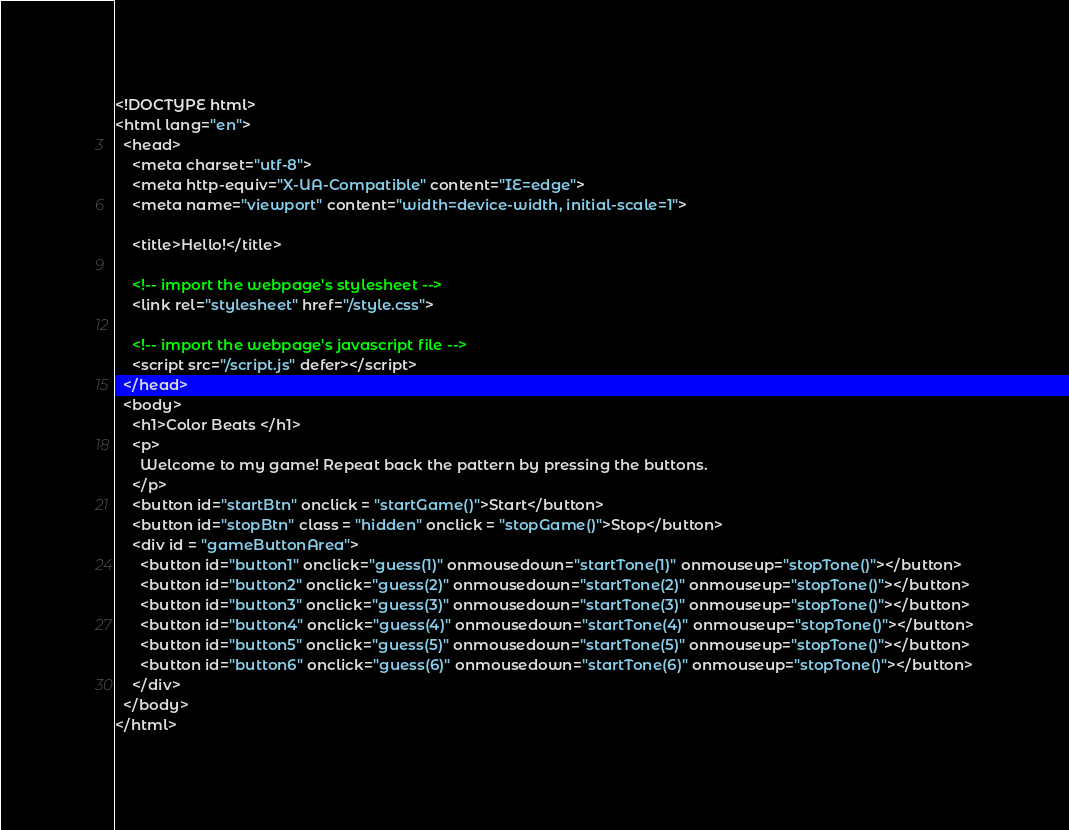Convert code to text. <code><loc_0><loc_0><loc_500><loc_500><_HTML_><!DOCTYPE html>
<html lang="en">
  <head>
    <meta charset="utf-8">
    <meta http-equiv="X-UA-Compatible" content="IE=edge">
    <meta name="viewport" content="width=device-width, initial-scale=1">

    <title>Hello!</title>
    
    <!-- import the webpage's stylesheet -->
    <link rel="stylesheet" href="/style.css">
    
    <!-- import the webpage's javascript file -->
    <script src="/script.js" defer></script>
  </head>  
  <body>
    <h1>Color Beats </h1>
    <p>
      Welcome to my game! Repeat back the pattern by pressing the buttons.
    </p>
    <button id="startBtn" onclick = "startGame()">Start</button>
    <button id="stopBtn" class = "hidden" onclick = "stopGame()">Stop</button>
    <div id = "gameButtonArea">
      <button id="button1" onclick="guess(1)" onmousedown="startTone(1)" onmouseup="stopTone()"></button>
      <button id="button2" onclick="guess(2)" onmousedown="startTone(2)" onmouseup="stopTone()"></button>
      <button id="button3" onclick="guess(3)" onmousedown="startTone(3)" onmouseup="stopTone()"></button>
      <button id="button4" onclick="guess(4)" onmousedown="startTone(4)" onmouseup="stopTone()"></button>
      <button id="button5" onclick="guess(5)" onmousedown="startTone(5)" onmouseup="stopTone()"></button>
      <button id="button6" onclick="guess(6)" onmousedown="startTone(6)" onmouseup="stopTone()"></button>
    </div>
  </body>
</html>
</code> 